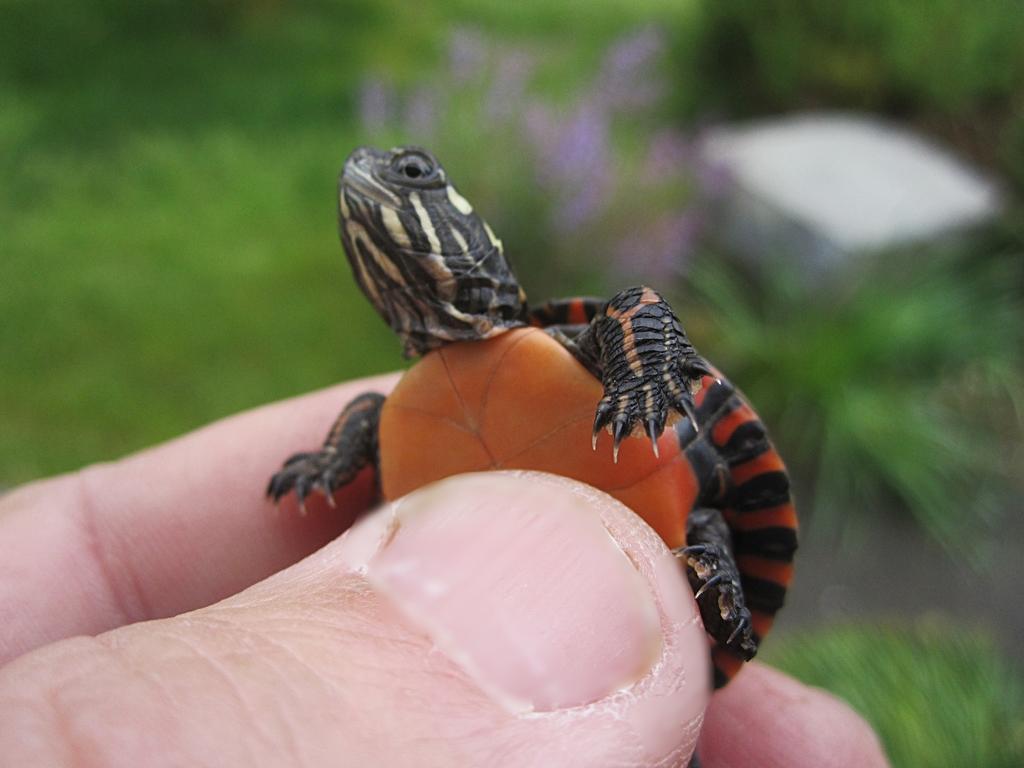Describe this image in one or two sentences. In the foreground of the image there are persons fingers holding a turtle. In the background of the image there are plants. There is grass. 